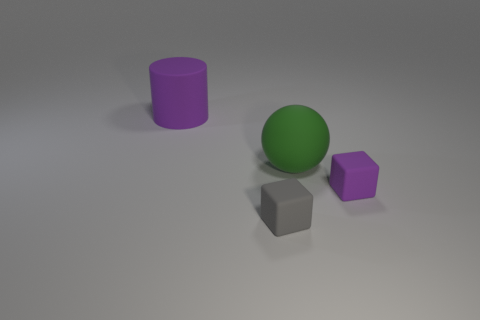Subtract all gray blocks. Subtract all brown cylinders. How many blocks are left? 1 Add 4 small rubber blocks. How many objects exist? 8 Subtract all cylinders. How many objects are left? 3 Subtract all purple matte cubes. Subtract all matte blocks. How many objects are left? 1 Add 2 tiny gray blocks. How many tiny gray blocks are left? 3 Add 1 big purple matte cylinders. How many big purple matte cylinders exist? 2 Subtract 0 blue cubes. How many objects are left? 4 